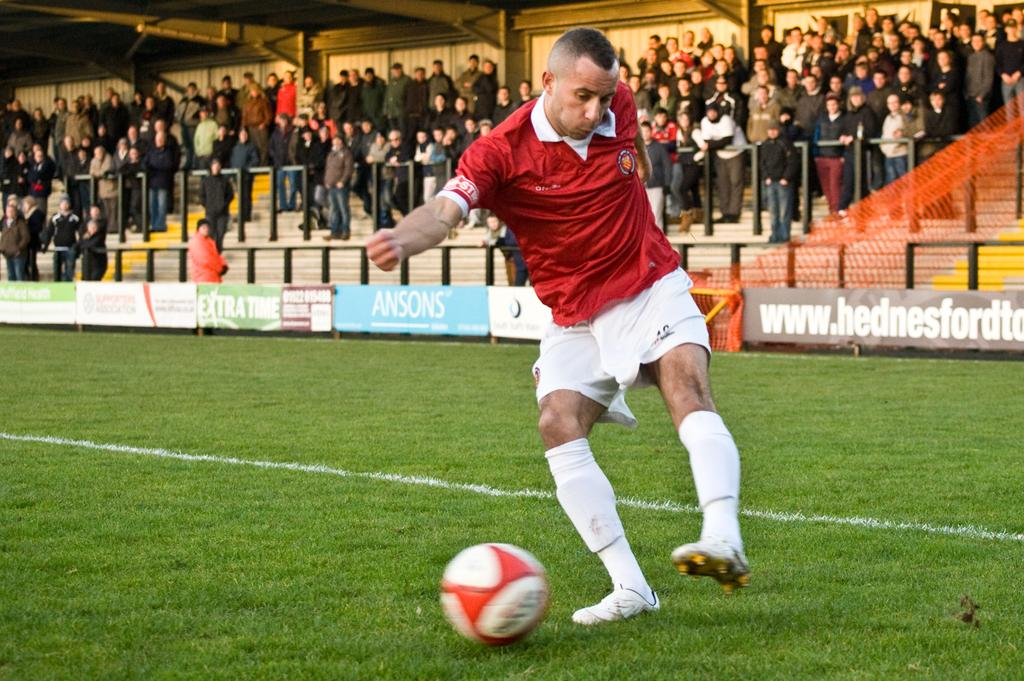<image>
Render a clear and concise summary of the photo. a soccer player in a field with a back banner that says 'ansons' 